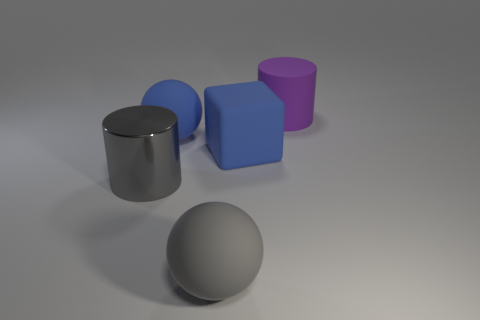Add 2 big purple rubber objects. How many objects exist? 7 Subtract all blocks. How many objects are left? 4 Subtract 1 balls. How many balls are left? 1 Subtract all brown cylinders. Subtract all brown cubes. How many cylinders are left? 2 Subtract all yellow shiny cubes. Subtract all purple cylinders. How many objects are left? 4 Add 2 purple rubber cylinders. How many purple rubber cylinders are left? 3 Add 4 big gray objects. How many big gray objects exist? 6 Subtract 0 purple blocks. How many objects are left? 5 